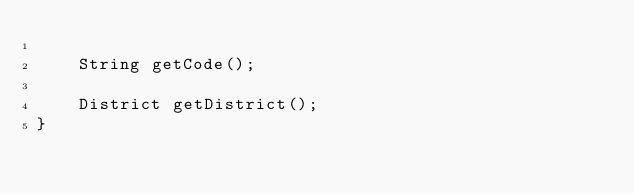Convert code to text. <code><loc_0><loc_0><loc_500><loc_500><_Java_>
    String getCode();

    District getDistrict();
}
</code> 